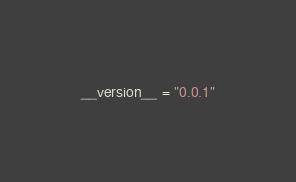Convert code to text. <code><loc_0><loc_0><loc_500><loc_500><_Python_>__version__ = "0.0.1"
</code> 